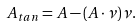Convert formula to latex. <formula><loc_0><loc_0><loc_500><loc_500>A _ { t a n } = A - ( A \cdot \nu ) \nu .</formula> 